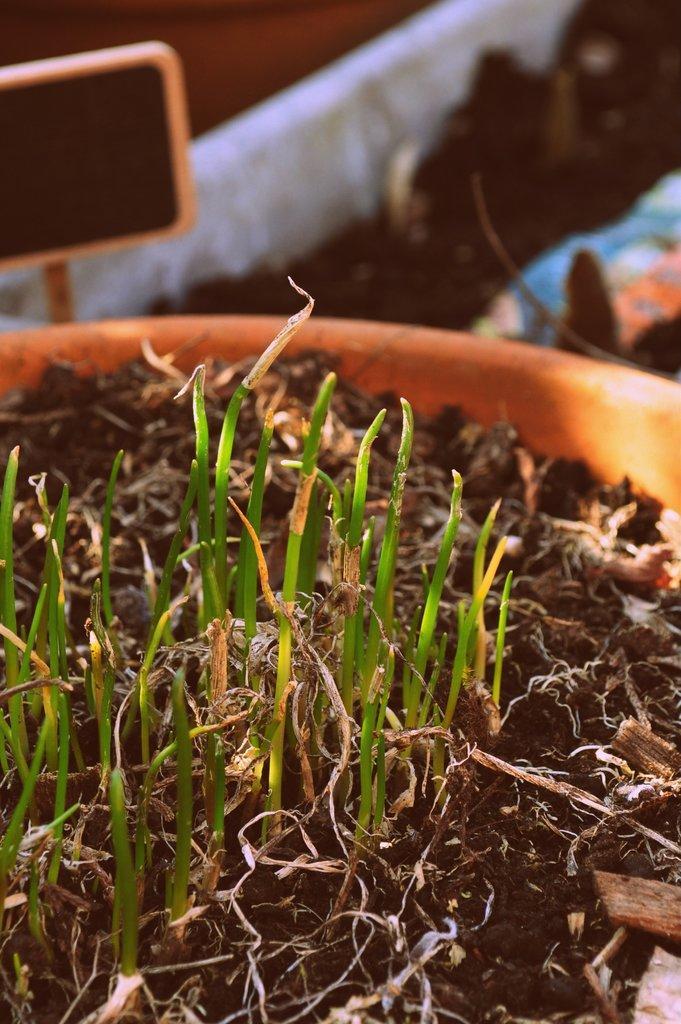In one or two sentences, can you explain what this image depicts? In the picture there is a pot with the mud, in the mud there are grass sprouts, beside there may be a mud. 